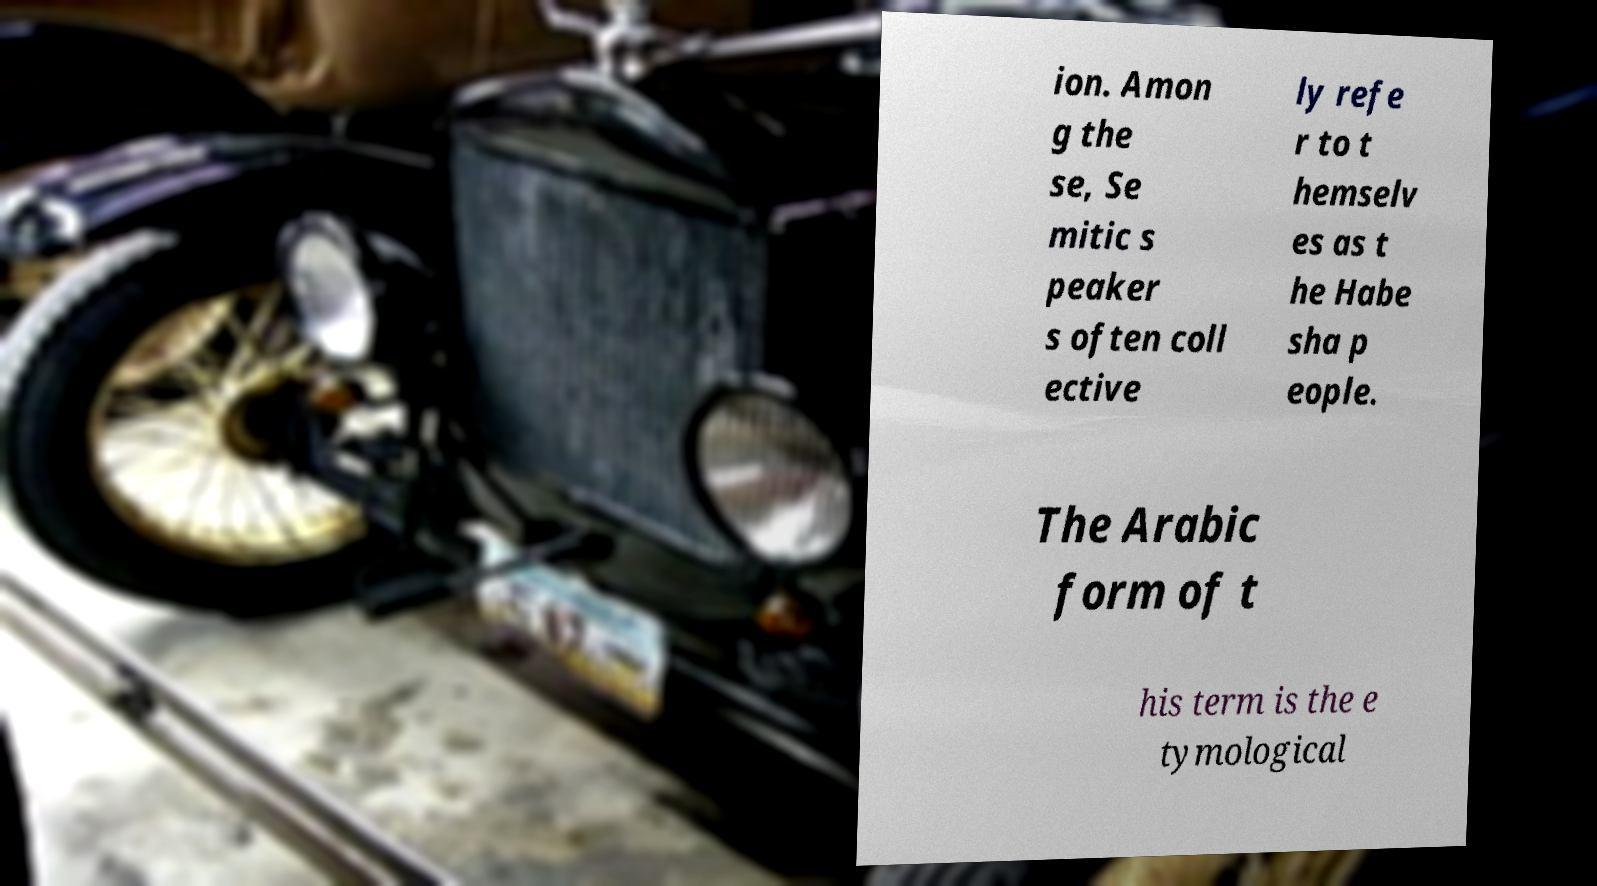Please read and relay the text visible in this image. What does it say? ion. Amon g the se, Se mitic s peaker s often coll ective ly refe r to t hemselv es as t he Habe sha p eople. The Arabic form of t his term is the e tymological 